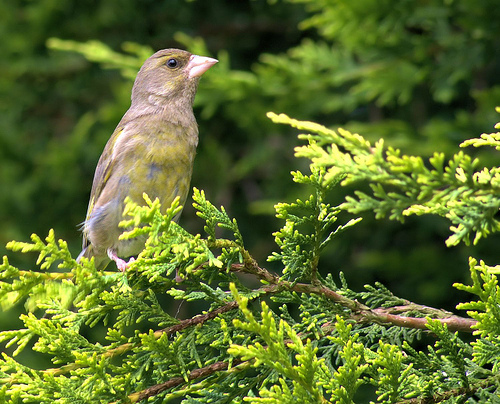What time of year does this bird likely breed? The European Greenfinch typically breeds in the late spring and early summer, often building their nests in shrubs or trees much like the one it's perched on in the image. 